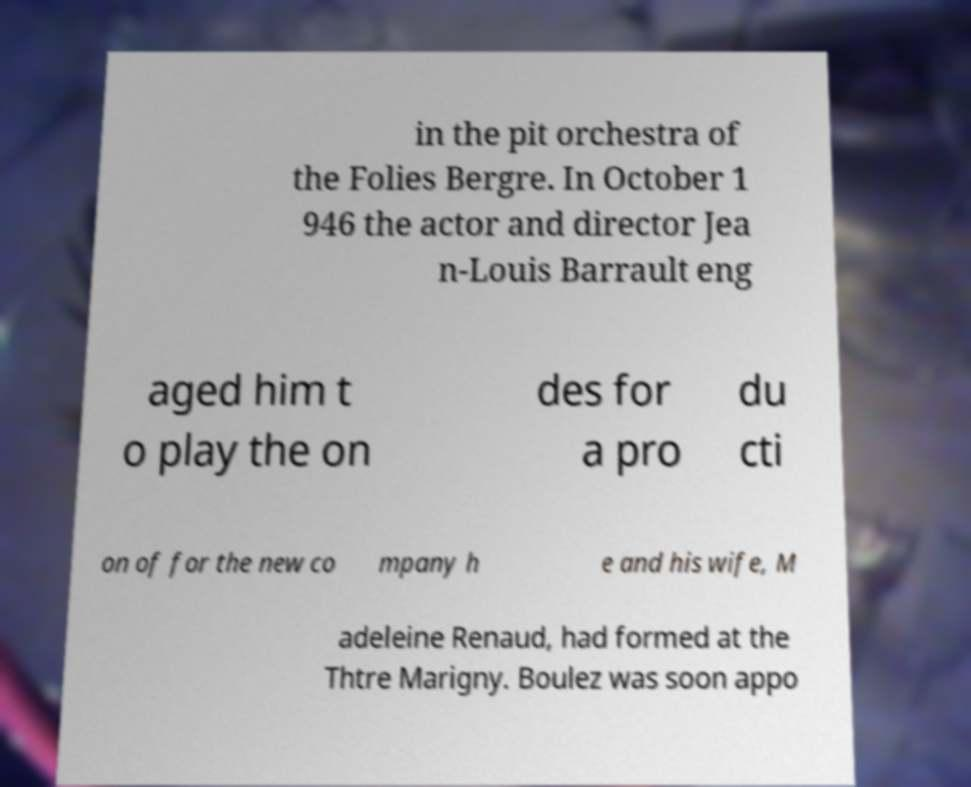What messages or text are displayed in this image? I need them in a readable, typed format. in the pit orchestra of the Folies Bergre. In October 1 946 the actor and director Jea n-Louis Barrault eng aged him t o play the on des for a pro du cti on of for the new co mpany h e and his wife, M adeleine Renaud, had formed at the Thtre Marigny. Boulez was soon appo 